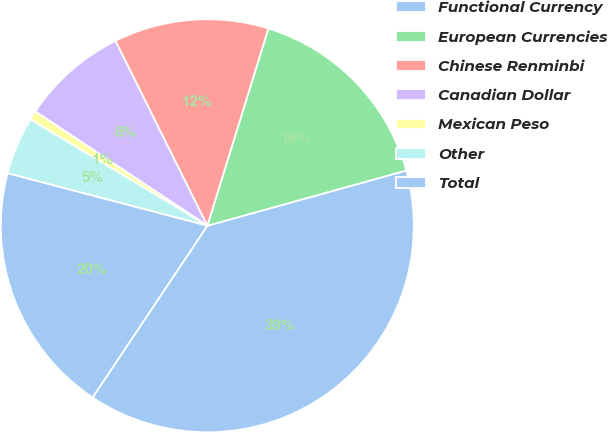Convert chart. <chart><loc_0><loc_0><loc_500><loc_500><pie_chart><fcel>Functional Currency<fcel>European Currencies<fcel>Chinese Renminbi<fcel>Canadian Dollar<fcel>Mexican Peso<fcel>Other<fcel>Total<nl><fcel>38.69%<fcel>15.91%<fcel>12.12%<fcel>8.32%<fcel>0.73%<fcel>4.52%<fcel>19.71%<nl></chart> 